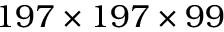Convert formula to latex. <formula><loc_0><loc_0><loc_500><loc_500>1 9 7 \times 1 9 7 \times 9 9</formula> 